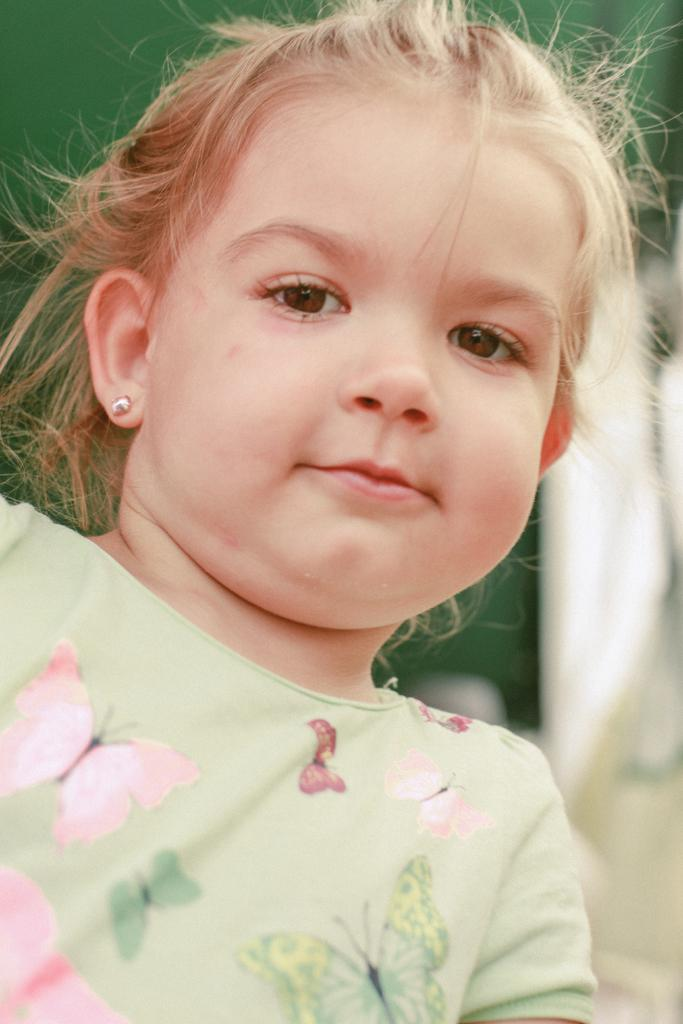Who is the main subject in the image? There is a girl in the image. What can be observed about the background of the image? The background of the image is blurred. What type of mark can be seen on the girl's sock in the image? There is no mention of a mark or sock in the image, so it cannot be determined from the image. 